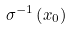<formula> <loc_0><loc_0><loc_500><loc_500>\sigma ^ { - 1 } \left ( x _ { 0 } \right )</formula> 